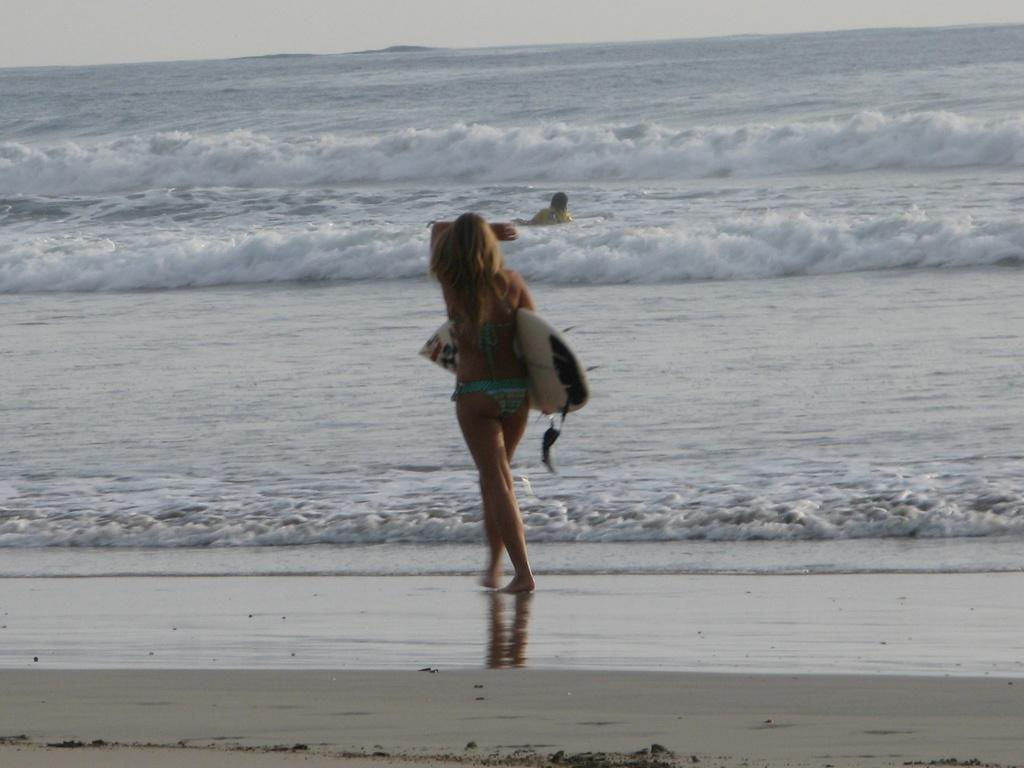What is happening in the image? There is a person in the image who is walking into the water. Where is the person located? The location is a beach. What is the person holding? The person is holding a surfing board. Can you tell me how many wheels are on the faucet in the image? There is no faucet present in the image, so it is not possible to determine the number of wheels on it. 